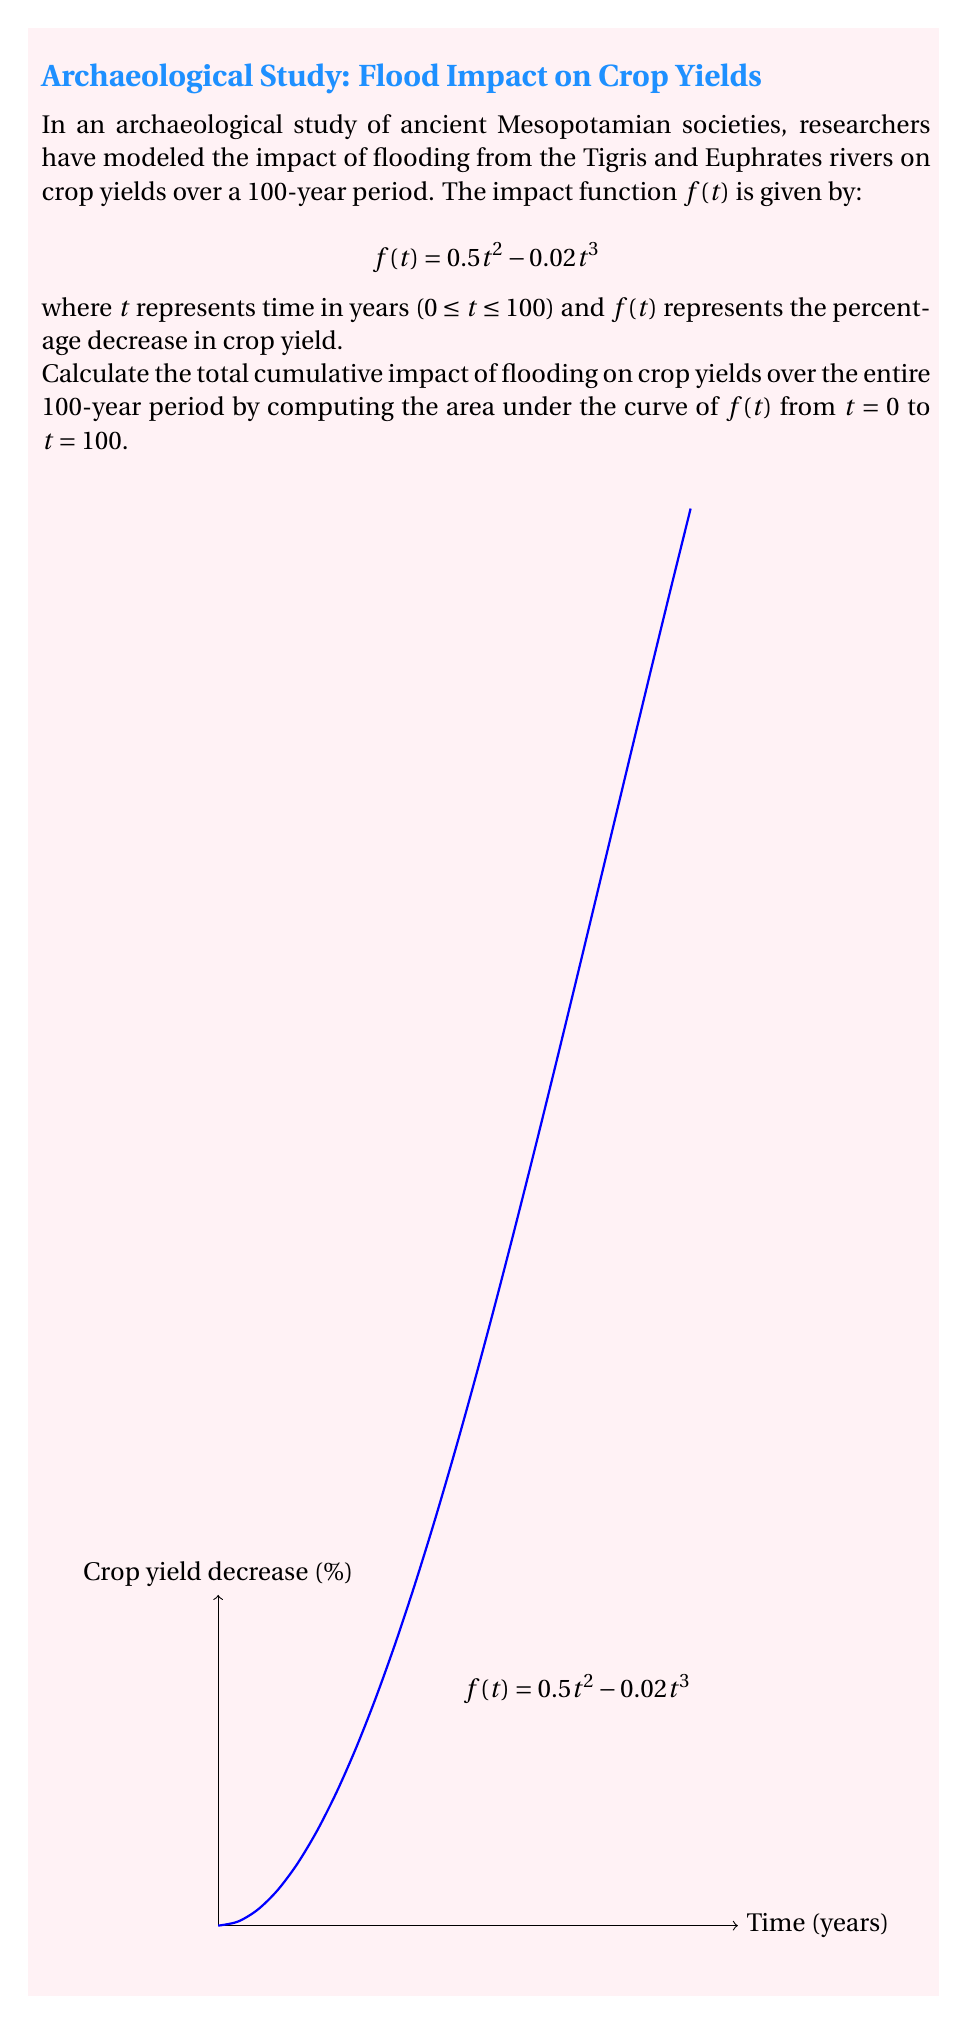Give your solution to this math problem. To calculate the area under the curve, we need to integrate the function $f(t)$ from 0 to 100. Let's approach this step-by-step:

1) The integral we need to evaluate is:

   $$\int_0^{100} (0.5t^2 - 0.02t^3) dt$$

2) Let's integrate each term separately:
   
   For $0.5t^2$: $\int 0.5t^2 dt = \frac{1}{3}(0.5)t^3 = \frac{1}{6}t^3$
   
   For $-0.02t^3$: $\int -0.02t^3 dt = -\frac{1}{4}(0.02)t^4 = -0.005t^4$

3) Combining these, we get:

   $$\int (0.5t^2 - 0.02t^3) dt = \frac{1}{6}t^3 - 0.005t^4 + C$$

4) Now, we need to evaluate this from 0 to 100:

   $$[\frac{1}{6}t^3 - 0.005t^4]_0^{100}$$

5) Plugging in the limits:

   $$(\frac{1}{6}(100)^3 - 0.005(100)^4) - (\frac{1}{6}(0)^3 - 0.005(0)^4)$$

6) Simplifying:

   $$(\frac{1}{6} \cdot 1,000,000 - 0.005 \cdot 100,000,000) - 0$$
   
   $$= 166,666.67 - 500,000 = -333,333.33$$

7) The negative value indicates a cumulative decrease in crop yield over the 100-year period.

This result represents the total percentage-years of crop yield decrease. To interpret this in the context of ancient Mesopotamian agriculture, it suggests a significant long-term impact of flooding on food production, which would have had profound effects on societal development and stability.
Answer: -333,333.33 percentage-years 